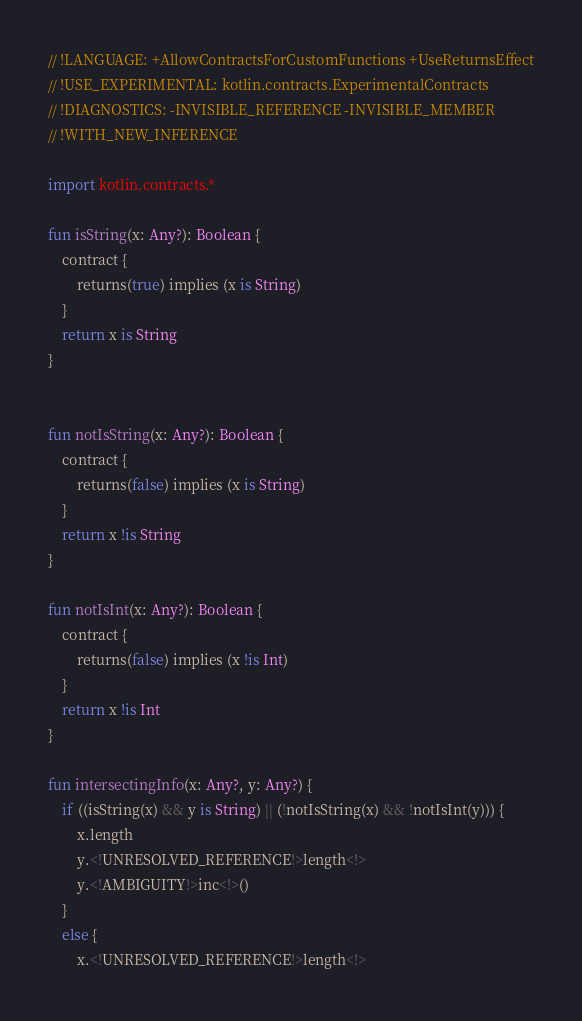Convert code to text. <code><loc_0><loc_0><loc_500><loc_500><_Kotlin_>// !LANGUAGE: +AllowContractsForCustomFunctions +UseReturnsEffect
// !USE_EXPERIMENTAL: kotlin.contracts.ExperimentalContracts
// !DIAGNOSTICS: -INVISIBLE_REFERENCE -INVISIBLE_MEMBER
// !WITH_NEW_INFERENCE

import kotlin.contracts.*

fun isString(x: Any?): Boolean {
    contract {
        returns(true) implies (x is String)
    }
    return x is String
}


fun notIsString(x: Any?): Boolean {
    contract {
        returns(false) implies (x is String)
    }
    return x !is String
}

fun notIsInt(x: Any?): Boolean {
    contract {
        returns(false) implies (x !is Int)
    }
    return x !is Int
}

fun intersectingInfo(x: Any?, y: Any?) {
    if ((isString(x) && y is String) || (!notIsString(x) && !notIsInt(y))) {
        x.length
        y.<!UNRESOLVED_REFERENCE!>length<!>
        y.<!AMBIGUITY!>inc<!>()
    }
    else {
        x.<!UNRESOLVED_REFERENCE!>length<!></code> 